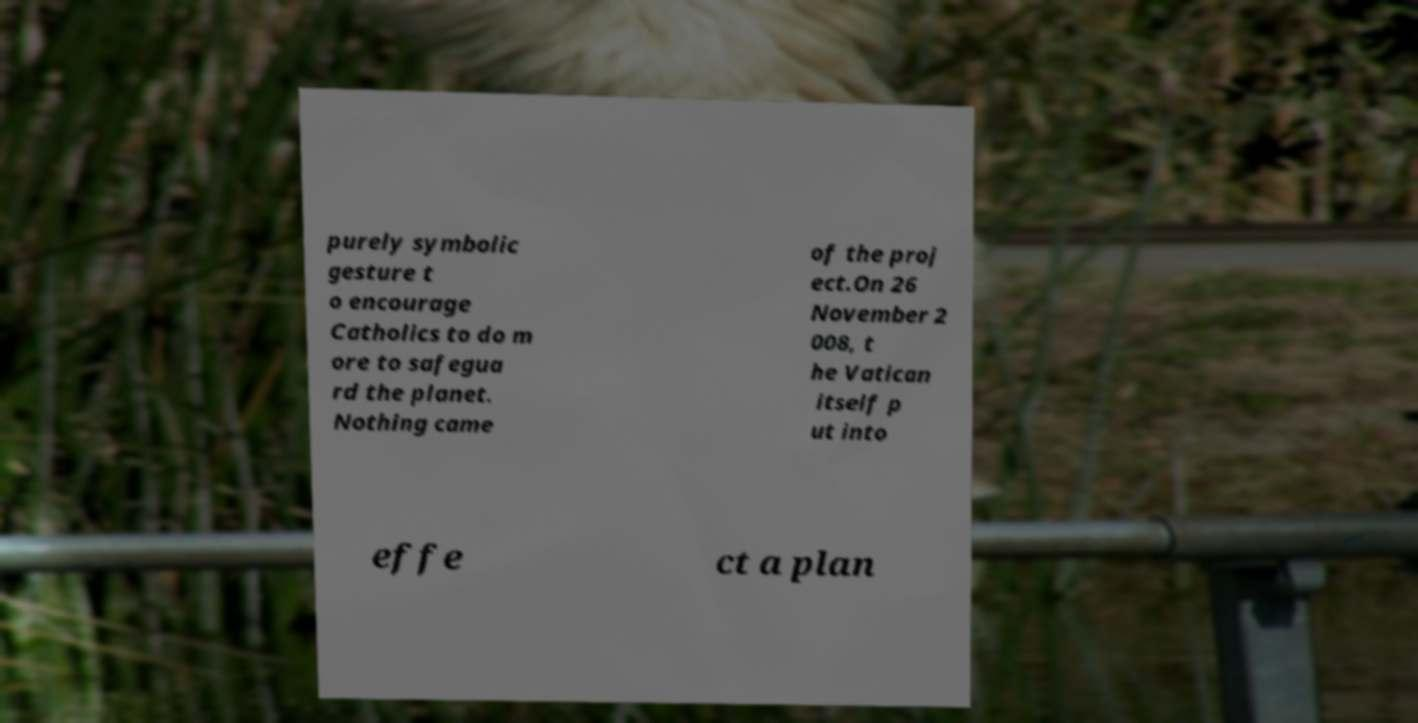I need the written content from this picture converted into text. Can you do that? purely symbolic gesture t o encourage Catholics to do m ore to safegua rd the planet. Nothing came of the proj ect.On 26 November 2 008, t he Vatican itself p ut into effe ct a plan 